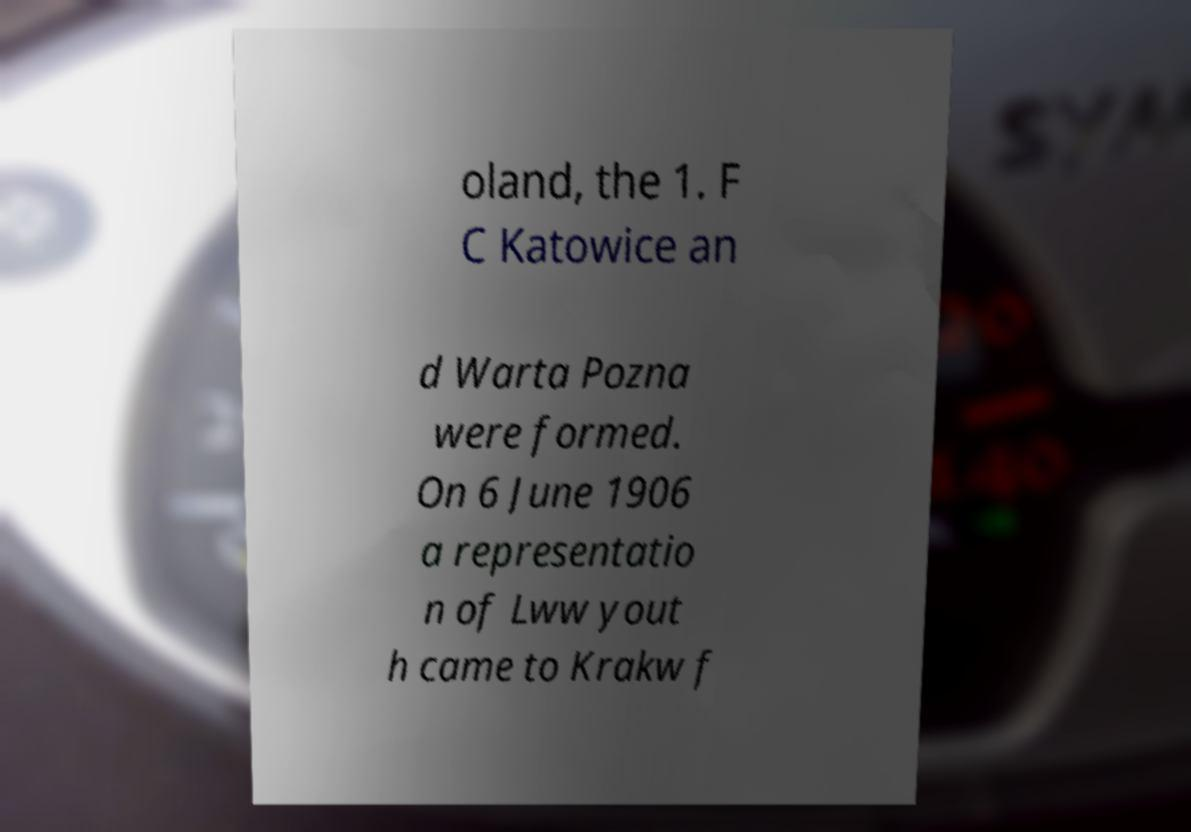Could you extract and type out the text from this image? oland, the 1. F C Katowice an d Warta Pozna were formed. On 6 June 1906 a representatio n of Lww yout h came to Krakw f 